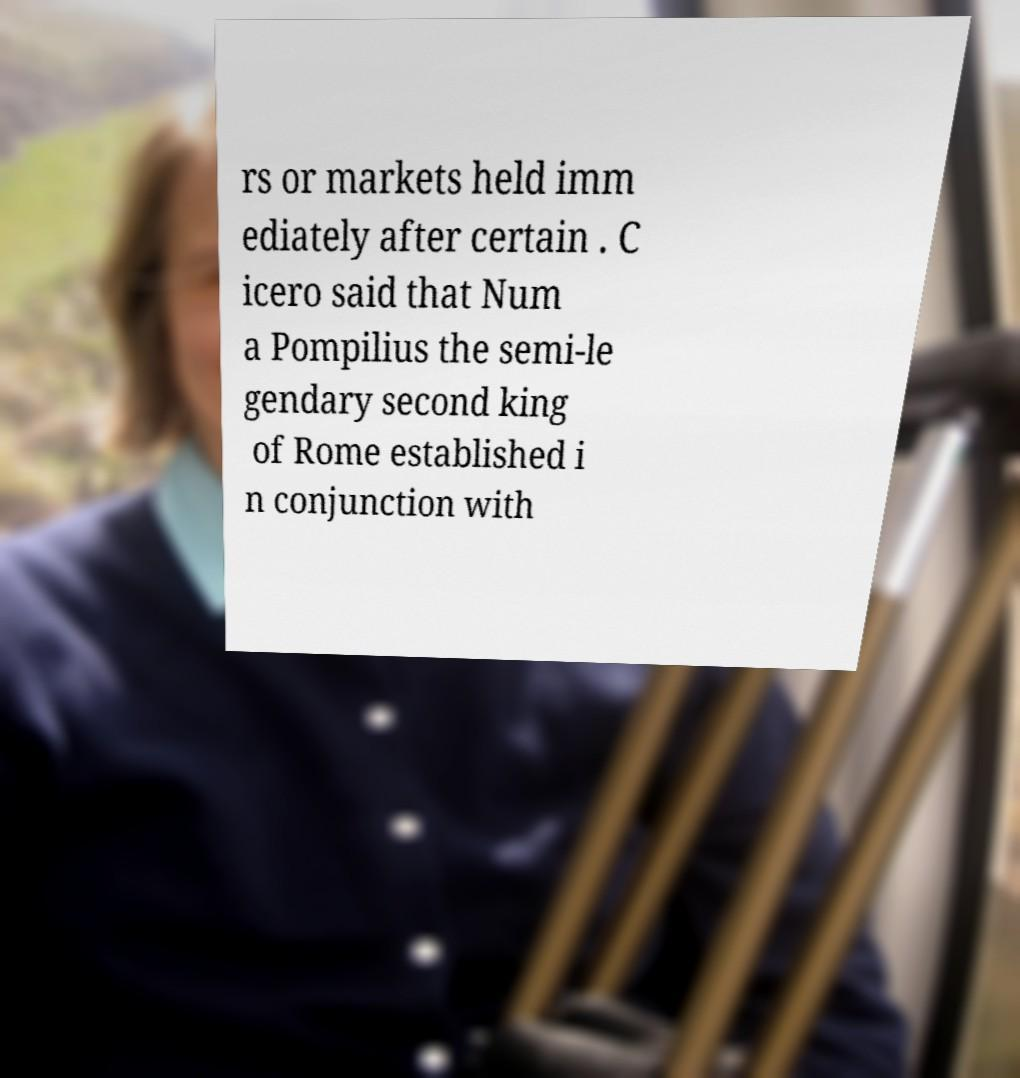Please read and relay the text visible in this image. What does it say? rs or markets held imm ediately after certain . C icero said that Num a Pompilius the semi-le gendary second king of Rome established i n conjunction with 